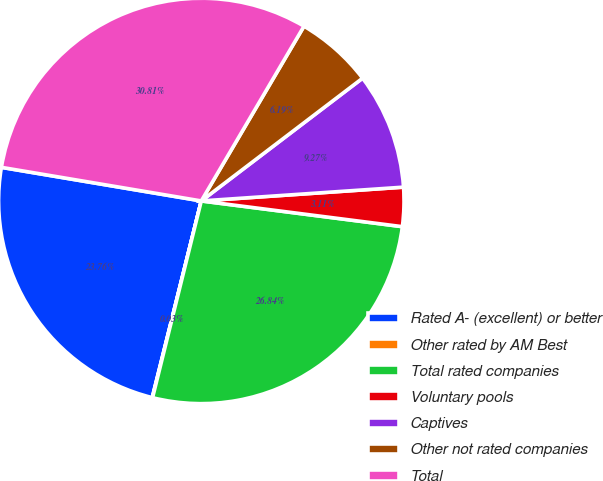<chart> <loc_0><loc_0><loc_500><loc_500><pie_chart><fcel>Rated A- (excellent) or better<fcel>Other rated by AM Best<fcel>Total rated companies<fcel>Voluntary pools<fcel>Captives<fcel>Other not rated companies<fcel>Total<nl><fcel>23.76%<fcel>0.03%<fcel>26.84%<fcel>3.11%<fcel>9.27%<fcel>6.19%<fcel>30.81%<nl></chart> 